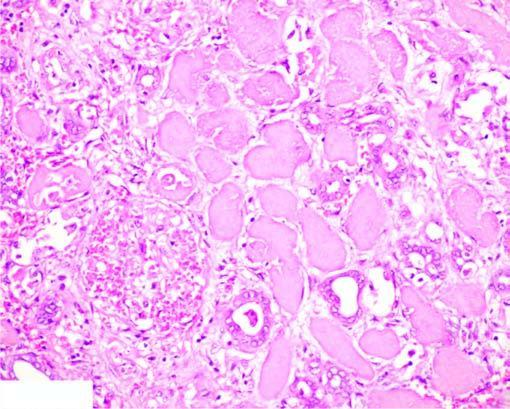how does the affected area on right show cells?
Answer the question using a single word or phrase. With intensely eosinophilic cytoplasm of tubular cells 